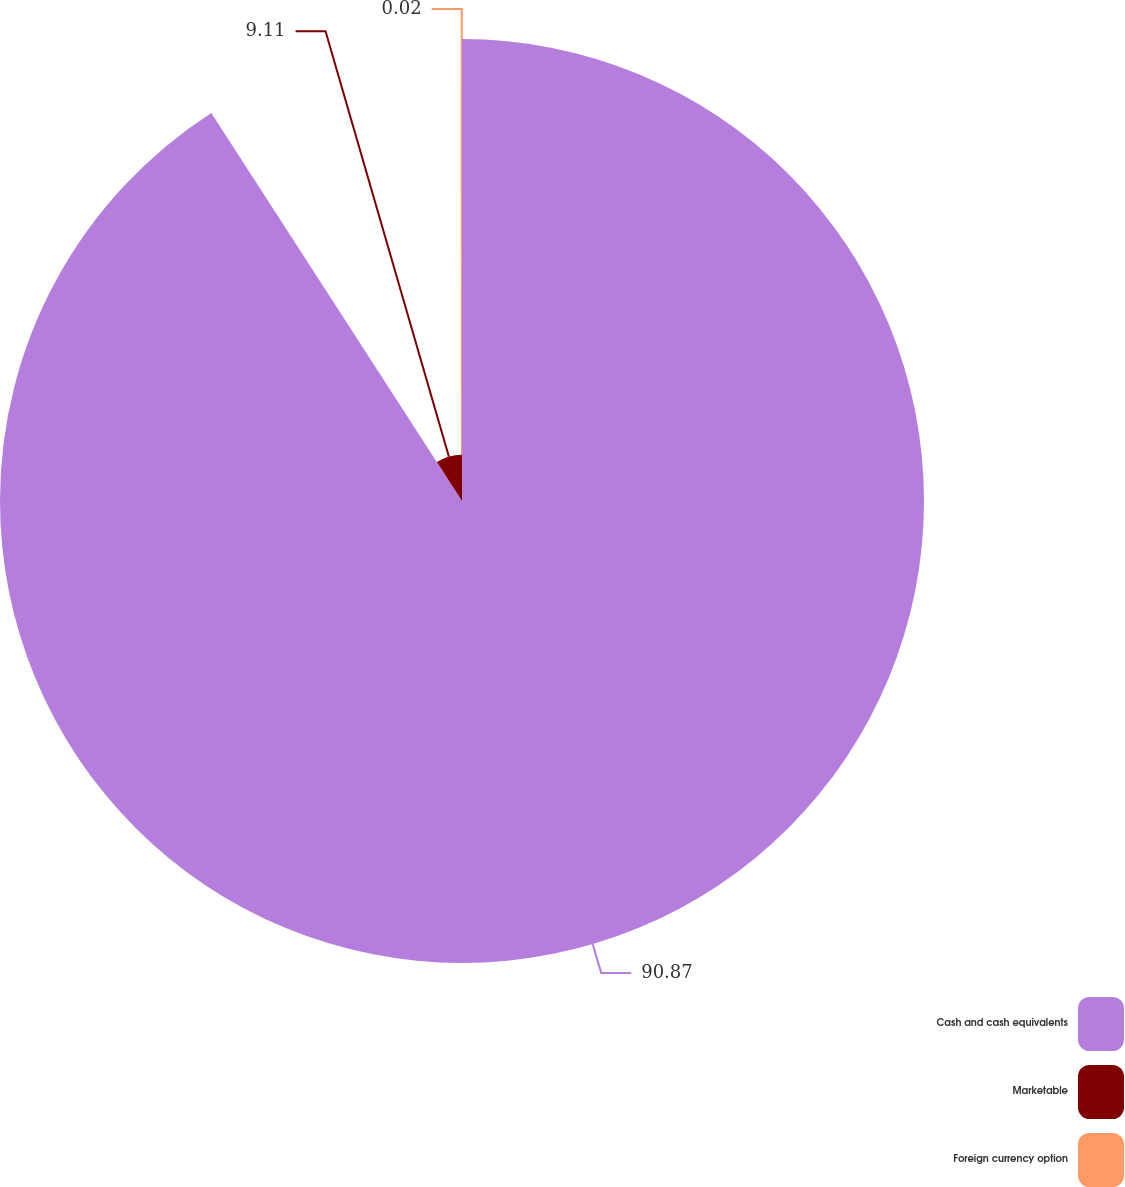<chart> <loc_0><loc_0><loc_500><loc_500><pie_chart><fcel>Cash and cash equivalents<fcel>Marketable<fcel>Foreign currency option<nl><fcel>90.87%<fcel>9.11%<fcel>0.02%<nl></chart> 